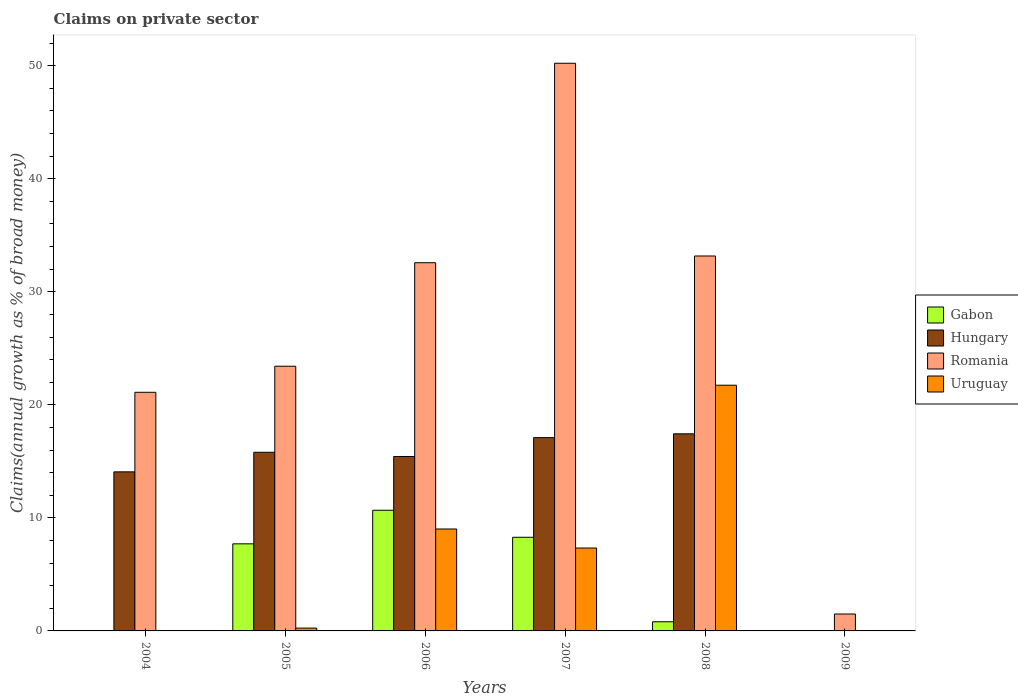How many different coloured bars are there?
Make the answer very short. 4. How many bars are there on the 1st tick from the left?
Your answer should be very brief. 2. How many bars are there on the 3rd tick from the right?
Make the answer very short. 4. What is the label of the 1st group of bars from the left?
Keep it short and to the point. 2004. In how many cases, is the number of bars for a given year not equal to the number of legend labels?
Offer a terse response. 2. What is the percentage of broad money claimed on private sector in Uruguay in 2008?
Make the answer very short. 21.74. Across all years, what is the maximum percentage of broad money claimed on private sector in Uruguay?
Provide a succinct answer. 21.74. Across all years, what is the minimum percentage of broad money claimed on private sector in Romania?
Give a very brief answer. 1.5. In which year was the percentage of broad money claimed on private sector in Hungary maximum?
Keep it short and to the point. 2008. What is the total percentage of broad money claimed on private sector in Romania in the graph?
Keep it short and to the point. 161.99. What is the difference between the percentage of broad money claimed on private sector in Hungary in 2005 and that in 2008?
Give a very brief answer. -1.63. What is the difference between the percentage of broad money claimed on private sector in Gabon in 2005 and the percentage of broad money claimed on private sector in Hungary in 2006?
Ensure brevity in your answer.  -7.73. What is the average percentage of broad money claimed on private sector in Gabon per year?
Provide a short and direct response. 4.58. In the year 2005, what is the difference between the percentage of broad money claimed on private sector in Gabon and percentage of broad money claimed on private sector in Hungary?
Make the answer very short. -8.1. What is the ratio of the percentage of broad money claimed on private sector in Hungary in 2005 to that in 2008?
Your response must be concise. 0.91. What is the difference between the highest and the second highest percentage of broad money claimed on private sector in Hungary?
Offer a very short reply. 0.34. What is the difference between the highest and the lowest percentage of broad money claimed on private sector in Hungary?
Your answer should be very brief. 17.44. Is the sum of the percentage of broad money claimed on private sector in Hungary in 2006 and 2007 greater than the maximum percentage of broad money claimed on private sector in Gabon across all years?
Offer a very short reply. Yes. Is it the case that in every year, the sum of the percentage of broad money claimed on private sector in Uruguay and percentage of broad money claimed on private sector in Romania is greater than the percentage of broad money claimed on private sector in Hungary?
Provide a succinct answer. Yes. Are all the bars in the graph horizontal?
Your response must be concise. No. How many years are there in the graph?
Your answer should be compact. 6. Where does the legend appear in the graph?
Your response must be concise. Center right. How many legend labels are there?
Give a very brief answer. 4. How are the legend labels stacked?
Your answer should be compact. Vertical. What is the title of the graph?
Offer a very short reply. Claims on private sector. Does "Mali" appear as one of the legend labels in the graph?
Your answer should be very brief. No. What is the label or title of the X-axis?
Your answer should be very brief. Years. What is the label or title of the Y-axis?
Offer a very short reply. Claims(annual growth as % of broad money). What is the Claims(annual growth as % of broad money) in Gabon in 2004?
Offer a terse response. 0. What is the Claims(annual growth as % of broad money) of Hungary in 2004?
Offer a very short reply. 14.07. What is the Claims(annual growth as % of broad money) in Romania in 2004?
Ensure brevity in your answer.  21.11. What is the Claims(annual growth as % of broad money) of Gabon in 2005?
Your answer should be compact. 7.7. What is the Claims(annual growth as % of broad money) of Hungary in 2005?
Provide a succinct answer. 15.8. What is the Claims(annual growth as % of broad money) in Romania in 2005?
Offer a very short reply. 23.42. What is the Claims(annual growth as % of broad money) of Uruguay in 2005?
Offer a very short reply. 0.25. What is the Claims(annual growth as % of broad money) of Gabon in 2006?
Ensure brevity in your answer.  10.68. What is the Claims(annual growth as % of broad money) in Hungary in 2006?
Give a very brief answer. 15.43. What is the Claims(annual growth as % of broad money) of Romania in 2006?
Your answer should be compact. 32.57. What is the Claims(annual growth as % of broad money) of Uruguay in 2006?
Provide a succinct answer. 9.02. What is the Claims(annual growth as % of broad money) in Gabon in 2007?
Your answer should be very brief. 8.28. What is the Claims(annual growth as % of broad money) in Hungary in 2007?
Make the answer very short. 17.1. What is the Claims(annual growth as % of broad money) in Romania in 2007?
Provide a succinct answer. 50.22. What is the Claims(annual growth as % of broad money) of Uruguay in 2007?
Ensure brevity in your answer.  7.33. What is the Claims(annual growth as % of broad money) in Gabon in 2008?
Offer a terse response. 0.81. What is the Claims(annual growth as % of broad money) in Hungary in 2008?
Give a very brief answer. 17.44. What is the Claims(annual growth as % of broad money) of Romania in 2008?
Your answer should be very brief. 33.17. What is the Claims(annual growth as % of broad money) of Uruguay in 2008?
Your answer should be compact. 21.74. What is the Claims(annual growth as % of broad money) in Gabon in 2009?
Make the answer very short. 0. What is the Claims(annual growth as % of broad money) in Hungary in 2009?
Give a very brief answer. 0. What is the Claims(annual growth as % of broad money) in Romania in 2009?
Make the answer very short. 1.5. What is the Claims(annual growth as % of broad money) in Uruguay in 2009?
Offer a very short reply. 0. Across all years, what is the maximum Claims(annual growth as % of broad money) of Gabon?
Offer a terse response. 10.68. Across all years, what is the maximum Claims(annual growth as % of broad money) in Hungary?
Your response must be concise. 17.44. Across all years, what is the maximum Claims(annual growth as % of broad money) in Romania?
Ensure brevity in your answer.  50.22. Across all years, what is the maximum Claims(annual growth as % of broad money) of Uruguay?
Give a very brief answer. 21.74. Across all years, what is the minimum Claims(annual growth as % of broad money) in Gabon?
Your response must be concise. 0. Across all years, what is the minimum Claims(annual growth as % of broad money) in Romania?
Provide a succinct answer. 1.5. What is the total Claims(annual growth as % of broad money) of Gabon in the graph?
Your response must be concise. 27.47. What is the total Claims(annual growth as % of broad money) in Hungary in the graph?
Keep it short and to the point. 79.84. What is the total Claims(annual growth as % of broad money) of Romania in the graph?
Offer a terse response. 161.99. What is the total Claims(annual growth as % of broad money) of Uruguay in the graph?
Ensure brevity in your answer.  38.34. What is the difference between the Claims(annual growth as % of broad money) in Hungary in 2004 and that in 2005?
Provide a short and direct response. -1.73. What is the difference between the Claims(annual growth as % of broad money) of Romania in 2004 and that in 2005?
Offer a very short reply. -2.31. What is the difference between the Claims(annual growth as % of broad money) in Hungary in 2004 and that in 2006?
Ensure brevity in your answer.  -1.36. What is the difference between the Claims(annual growth as % of broad money) of Romania in 2004 and that in 2006?
Give a very brief answer. -11.46. What is the difference between the Claims(annual growth as % of broad money) of Hungary in 2004 and that in 2007?
Give a very brief answer. -3.03. What is the difference between the Claims(annual growth as % of broad money) of Romania in 2004 and that in 2007?
Ensure brevity in your answer.  -29.11. What is the difference between the Claims(annual growth as % of broad money) in Hungary in 2004 and that in 2008?
Offer a very short reply. -3.36. What is the difference between the Claims(annual growth as % of broad money) of Romania in 2004 and that in 2008?
Offer a terse response. -12.06. What is the difference between the Claims(annual growth as % of broad money) of Romania in 2004 and that in 2009?
Your answer should be very brief. 19.61. What is the difference between the Claims(annual growth as % of broad money) of Gabon in 2005 and that in 2006?
Your response must be concise. -2.97. What is the difference between the Claims(annual growth as % of broad money) in Hungary in 2005 and that in 2006?
Your response must be concise. 0.37. What is the difference between the Claims(annual growth as % of broad money) of Romania in 2005 and that in 2006?
Offer a very short reply. -9.16. What is the difference between the Claims(annual growth as % of broad money) of Uruguay in 2005 and that in 2006?
Provide a succinct answer. -8.77. What is the difference between the Claims(annual growth as % of broad money) of Gabon in 2005 and that in 2007?
Provide a succinct answer. -0.58. What is the difference between the Claims(annual growth as % of broad money) in Hungary in 2005 and that in 2007?
Keep it short and to the point. -1.3. What is the difference between the Claims(annual growth as % of broad money) in Romania in 2005 and that in 2007?
Give a very brief answer. -26.8. What is the difference between the Claims(annual growth as % of broad money) of Uruguay in 2005 and that in 2007?
Keep it short and to the point. -7.08. What is the difference between the Claims(annual growth as % of broad money) of Gabon in 2005 and that in 2008?
Keep it short and to the point. 6.89. What is the difference between the Claims(annual growth as % of broad money) in Hungary in 2005 and that in 2008?
Your response must be concise. -1.63. What is the difference between the Claims(annual growth as % of broad money) in Romania in 2005 and that in 2008?
Offer a very short reply. -9.75. What is the difference between the Claims(annual growth as % of broad money) of Uruguay in 2005 and that in 2008?
Your response must be concise. -21.49. What is the difference between the Claims(annual growth as % of broad money) in Romania in 2005 and that in 2009?
Offer a terse response. 21.92. What is the difference between the Claims(annual growth as % of broad money) of Gabon in 2006 and that in 2007?
Provide a short and direct response. 2.39. What is the difference between the Claims(annual growth as % of broad money) in Hungary in 2006 and that in 2007?
Your response must be concise. -1.67. What is the difference between the Claims(annual growth as % of broad money) of Romania in 2006 and that in 2007?
Offer a terse response. -17.65. What is the difference between the Claims(annual growth as % of broad money) in Uruguay in 2006 and that in 2007?
Provide a short and direct response. 1.68. What is the difference between the Claims(annual growth as % of broad money) in Gabon in 2006 and that in 2008?
Provide a short and direct response. 9.86. What is the difference between the Claims(annual growth as % of broad money) in Hungary in 2006 and that in 2008?
Make the answer very short. -2.01. What is the difference between the Claims(annual growth as % of broad money) in Romania in 2006 and that in 2008?
Your answer should be compact. -0.6. What is the difference between the Claims(annual growth as % of broad money) of Uruguay in 2006 and that in 2008?
Provide a short and direct response. -12.72. What is the difference between the Claims(annual growth as % of broad money) of Romania in 2006 and that in 2009?
Keep it short and to the point. 31.08. What is the difference between the Claims(annual growth as % of broad money) in Gabon in 2007 and that in 2008?
Ensure brevity in your answer.  7.47. What is the difference between the Claims(annual growth as % of broad money) of Hungary in 2007 and that in 2008?
Offer a very short reply. -0.34. What is the difference between the Claims(annual growth as % of broad money) of Romania in 2007 and that in 2008?
Offer a terse response. 17.05. What is the difference between the Claims(annual growth as % of broad money) of Uruguay in 2007 and that in 2008?
Make the answer very short. -14.4. What is the difference between the Claims(annual growth as % of broad money) in Romania in 2007 and that in 2009?
Ensure brevity in your answer.  48.72. What is the difference between the Claims(annual growth as % of broad money) of Romania in 2008 and that in 2009?
Offer a terse response. 31.67. What is the difference between the Claims(annual growth as % of broad money) of Hungary in 2004 and the Claims(annual growth as % of broad money) of Romania in 2005?
Offer a terse response. -9.34. What is the difference between the Claims(annual growth as % of broad money) in Hungary in 2004 and the Claims(annual growth as % of broad money) in Uruguay in 2005?
Provide a short and direct response. 13.82. What is the difference between the Claims(annual growth as % of broad money) in Romania in 2004 and the Claims(annual growth as % of broad money) in Uruguay in 2005?
Provide a succinct answer. 20.86. What is the difference between the Claims(annual growth as % of broad money) in Hungary in 2004 and the Claims(annual growth as % of broad money) in Romania in 2006?
Provide a succinct answer. -18.5. What is the difference between the Claims(annual growth as % of broad money) of Hungary in 2004 and the Claims(annual growth as % of broad money) of Uruguay in 2006?
Offer a terse response. 5.05. What is the difference between the Claims(annual growth as % of broad money) of Romania in 2004 and the Claims(annual growth as % of broad money) of Uruguay in 2006?
Keep it short and to the point. 12.09. What is the difference between the Claims(annual growth as % of broad money) of Hungary in 2004 and the Claims(annual growth as % of broad money) of Romania in 2007?
Your response must be concise. -36.15. What is the difference between the Claims(annual growth as % of broad money) of Hungary in 2004 and the Claims(annual growth as % of broad money) of Uruguay in 2007?
Keep it short and to the point. 6.74. What is the difference between the Claims(annual growth as % of broad money) in Romania in 2004 and the Claims(annual growth as % of broad money) in Uruguay in 2007?
Ensure brevity in your answer.  13.78. What is the difference between the Claims(annual growth as % of broad money) in Hungary in 2004 and the Claims(annual growth as % of broad money) in Romania in 2008?
Offer a terse response. -19.1. What is the difference between the Claims(annual growth as % of broad money) of Hungary in 2004 and the Claims(annual growth as % of broad money) of Uruguay in 2008?
Ensure brevity in your answer.  -7.66. What is the difference between the Claims(annual growth as % of broad money) in Romania in 2004 and the Claims(annual growth as % of broad money) in Uruguay in 2008?
Provide a short and direct response. -0.63. What is the difference between the Claims(annual growth as % of broad money) in Hungary in 2004 and the Claims(annual growth as % of broad money) in Romania in 2009?
Offer a terse response. 12.58. What is the difference between the Claims(annual growth as % of broad money) of Gabon in 2005 and the Claims(annual growth as % of broad money) of Hungary in 2006?
Your answer should be very brief. -7.73. What is the difference between the Claims(annual growth as % of broad money) of Gabon in 2005 and the Claims(annual growth as % of broad money) of Romania in 2006?
Give a very brief answer. -24.87. What is the difference between the Claims(annual growth as % of broad money) of Gabon in 2005 and the Claims(annual growth as % of broad money) of Uruguay in 2006?
Provide a short and direct response. -1.31. What is the difference between the Claims(annual growth as % of broad money) of Hungary in 2005 and the Claims(annual growth as % of broad money) of Romania in 2006?
Provide a short and direct response. -16.77. What is the difference between the Claims(annual growth as % of broad money) of Hungary in 2005 and the Claims(annual growth as % of broad money) of Uruguay in 2006?
Your response must be concise. 6.79. What is the difference between the Claims(annual growth as % of broad money) in Romania in 2005 and the Claims(annual growth as % of broad money) in Uruguay in 2006?
Make the answer very short. 14.4. What is the difference between the Claims(annual growth as % of broad money) in Gabon in 2005 and the Claims(annual growth as % of broad money) in Hungary in 2007?
Offer a very short reply. -9.4. What is the difference between the Claims(annual growth as % of broad money) in Gabon in 2005 and the Claims(annual growth as % of broad money) in Romania in 2007?
Make the answer very short. -42.52. What is the difference between the Claims(annual growth as % of broad money) of Gabon in 2005 and the Claims(annual growth as % of broad money) of Uruguay in 2007?
Keep it short and to the point. 0.37. What is the difference between the Claims(annual growth as % of broad money) in Hungary in 2005 and the Claims(annual growth as % of broad money) in Romania in 2007?
Your answer should be very brief. -34.42. What is the difference between the Claims(annual growth as % of broad money) of Hungary in 2005 and the Claims(annual growth as % of broad money) of Uruguay in 2007?
Provide a short and direct response. 8.47. What is the difference between the Claims(annual growth as % of broad money) of Romania in 2005 and the Claims(annual growth as % of broad money) of Uruguay in 2007?
Provide a succinct answer. 16.08. What is the difference between the Claims(annual growth as % of broad money) in Gabon in 2005 and the Claims(annual growth as % of broad money) in Hungary in 2008?
Ensure brevity in your answer.  -9.73. What is the difference between the Claims(annual growth as % of broad money) in Gabon in 2005 and the Claims(annual growth as % of broad money) in Romania in 2008?
Your answer should be very brief. -25.46. What is the difference between the Claims(annual growth as % of broad money) of Gabon in 2005 and the Claims(annual growth as % of broad money) of Uruguay in 2008?
Give a very brief answer. -14.03. What is the difference between the Claims(annual growth as % of broad money) in Hungary in 2005 and the Claims(annual growth as % of broad money) in Romania in 2008?
Your response must be concise. -17.36. What is the difference between the Claims(annual growth as % of broad money) of Hungary in 2005 and the Claims(annual growth as % of broad money) of Uruguay in 2008?
Provide a short and direct response. -5.93. What is the difference between the Claims(annual growth as % of broad money) of Romania in 2005 and the Claims(annual growth as % of broad money) of Uruguay in 2008?
Ensure brevity in your answer.  1.68. What is the difference between the Claims(annual growth as % of broad money) in Gabon in 2005 and the Claims(annual growth as % of broad money) in Romania in 2009?
Your answer should be very brief. 6.21. What is the difference between the Claims(annual growth as % of broad money) of Hungary in 2005 and the Claims(annual growth as % of broad money) of Romania in 2009?
Ensure brevity in your answer.  14.31. What is the difference between the Claims(annual growth as % of broad money) in Gabon in 2006 and the Claims(annual growth as % of broad money) in Hungary in 2007?
Your response must be concise. -6.42. What is the difference between the Claims(annual growth as % of broad money) of Gabon in 2006 and the Claims(annual growth as % of broad money) of Romania in 2007?
Provide a short and direct response. -39.54. What is the difference between the Claims(annual growth as % of broad money) in Gabon in 2006 and the Claims(annual growth as % of broad money) in Uruguay in 2007?
Your response must be concise. 3.34. What is the difference between the Claims(annual growth as % of broad money) of Hungary in 2006 and the Claims(annual growth as % of broad money) of Romania in 2007?
Provide a short and direct response. -34.79. What is the difference between the Claims(annual growth as % of broad money) of Hungary in 2006 and the Claims(annual growth as % of broad money) of Uruguay in 2007?
Your response must be concise. 8.1. What is the difference between the Claims(annual growth as % of broad money) in Romania in 2006 and the Claims(annual growth as % of broad money) in Uruguay in 2007?
Make the answer very short. 25.24. What is the difference between the Claims(annual growth as % of broad money) in Gabon in 2006 and the Claims(annual growth as % of broad money) in Hungary in 2008?
Provide a short and direct response. -6.76. What is the difference between the Claims(annual growth as % of broad money) of Gabon in 2006 and the Claims(annual growth as % of broad money) of Romania in 2008?
Offer a very short reply. -22.49. What is the difference between the Claims(annual growth as % of broad money) of Gabon in 2006 and the Claims(annual growth as % of broad money) of Uruguay in 2008?
Provide a short and direct response. -11.06. What is the difference between the Claims(annual growth as % of broad money) of Hungary in 2006 and the Claims(annual growth as % of broad money) of Romania in 2008?
Give a very brief answer. -17.74. What is the difference between the Claims(annual growth as % of broad money) in Hungary in 2006 and the Claims(annual growth as % of broad money) in Uruguay in 2008?
Your response must be concise. -6.31. What is the difference between the Claims(annual growth as % of broad money) in Romania in 2006 and the Claims(annual growth as % of broad money) in Uruguay in 2008?
Your answer should be compact. 10.84. What is the difference between the Claims(annual growth as % of broad money) in Gabon in 2006 and the Claims(annual growth as % of broad money) in Romania in 2009?
Provide a succinct answer. 9.18. What is the difference between the Claims(annual growth as % of broad money) in Hungary in 2006 and the Claims(annual growth as % of broad money) in Romania in 2009?
Keep it short and to the point. 13.93. What is the difference between the Claims(annual growth as % of broad money) in Gabon in 2007 and the Claims(annual growth as % of broad money) in Hungary in 2008?
Offer a terse response. -9.15. What is the difference between the Claims(annual growth as % of broad money) of Gabon in 2007 and the Claims(annual growth as % of broad money) of Romania in 2008?
Give a very brief answer. -24.88. What is the difference between the Claims(annual growth as % of broad money) in Gabon in 2007 and the Claims(annual growth as % of broad money) in Uruguay in 2008?
Give a very brief answer. -13.45. What is the difference between the Claims(annual growth as % of broad money) in Hungary in 2007 and the Claims(annual growth as % of broad money) in Romania in 2008?
Provide a succinct answer. -16.07. What is the difference between the Claims(annual growth as % of broad money) in Hungary in 2007 and the Claims(annual growth as % of broad money) in Uruguay in 2008?
Your answer should be very brief. -4.64. What is the difference between the Claims(annual growth as % of broad money) in Romania in 2007 and the Claims(annual growth as % of broad money) in Uruguay in 2008?
Give a very brief answer. 28.48. What is the difference between the Claims(annual growth as % of broad money) of Gabon in 2007 and the Claims(annual growth as % of broad money) of Romania in 2009?
Ensure brevity in your answer.  6.79. What is the difference between the Claims(annual growth as % of broad money) in Hungary in 2007 and the Claims(annual growth as % of broad money) in Romania in 2009?
Your response must be concise. 15.6. What is the difference between the Claims(annual growth as % of broad money) of Gabon in 2008 and the Claims(annual growth as % of broad money) of Romania in 2009?
Keep it short and to the point. -0.69. What is the difference between the Claims(annual growth as % of broad money) of Hungary in 2008 and the Claims(annual growth as % of broad money) of Romania in 2009?
Make the answer very short. 15.94. What is the average Claims(annual growth as % of broad money) of Gabon per year?
Offer a very short reply. 4.58. What is the average Claims(annual growth as % of broad money) of Hungary per year?
Give a very brief answer. 13.31. What is the average Claims(annual growth as % of broad money) of Romania per year?
Your answer should be very brief. 27. What is the average Claims(annual growth as % of broad money) in Uruguay per year?
Your answer should be very brief. 6.39. In the year 2004, what is the difference between the Claims(annual growth as % of broad money) of Hungary and Claims(annual growth as % of broad money) of Romania?
Offer a very short reply. -7.04. In the year 2005, what is the difference between the Claims(annual growth as % of broad money) of Gabon and Claims(annual growth as % of broad money) of Hungary?
Your answer should be very brief. -8.1. In the year 2005, what is the difference between the Claims(annual growth as % of broad money) in Gabon and Claims(annual growth as % of broad money) in Romania?
Your answer should be compact. -15.71. In the year 2005, what is the difference between the Claims(annual growth as % of broad money) in Gabon and Claims(annual growth as % of broad money) in Uruguay?
Offer a very short reply. 7.45. In the year 2005, what is the difference between the Claims(annual growth as % of broad money) of Hungary and Claims(annual growth as % of broad money) of Romania?
Your response must be concise. -7.61. In the year 2005, what is the difference between the Claims(annual growth as % of broad money) in Hungary and Claims(annual growth as % of broad money) in Uruguay?
Your answer should be compact. 15.55. In the year 2005, what is the difference between the Claims(annual growth as % of broad money) of Romania and Claims(annual growth as % of broad money) of Uruguay?
Your answer should be very brief. 23.17. In the year 2006, what is the difference between the Claims(annual growth as % of broad money) of Gabon and Claims(annual growth as % of broad money) of Hungary?
Ensure brevity in your answer.  -4.76. In the year 2006, what is the difference between the Claims(annual growth as % of broad money) of Gabon and Claims(annual growth as % of broad money) of Romania?
Keep it short and to the point. -21.9. In the year 2006, what is the difference between the Claims(annual growth as % of broad money) in Gabon and Claims(annual growth as % of broad money) in Uruguay?
Ensure brevity in your answer.  1.66. In the year 2006, what is the difference between the Claims(annual growth as % of broad money) in Hungary and Claims(annual growth as % of broad money) in Romania?
Your answer should be compact. -17.14. In the year 2006, what is the difference between the Claims(annual growth as % of broad money) of Hungary and Claims(annual growth as % of broad money) of Uruguay?
Your response must be concise. 6.41. In the year 2006, what is the difference between the Claims(annual growth as % of broad money) in Romania and Claims(annual growth as % of broad money) in Uruguay?
Make the answer very short. 23.55. In the year 2007, what is the difference between the Claims(annual growth as % of broad money) of Gabon and Claims(annual growth as % of broad money) of Hungary?
Make the answer very short. -8.82. In the year 2007, what is the difference between the Claims(annual growth as % of broad money) in Gabon and Claims(annual growth as % of broad money) in Romania?
Provide a succinct answer. -41.94. In the year 2007, what is the difference between the Claims(annual growth as % of broad money) in Gabon and Claims(annual growth as % of broad money) in Uruguay?
Provide a short and direct response. 0.95. In the year 2007, what is the difference between the Claims(annual growth as % of broad money) of Hungary and Claims(annual growth as % of broad money) of Romania?
Offer a very short reply. -33.12. In the year 2007, what is the difference between the Claims(annual growth as % of broad money) of Hungary and Claims(annual growth as % of broad money) of Uruguay?
Offer a terse response. 9.77. In the year 2007, what is the difference between the Claims(annual growth as % of broad money) in Romania and Claims(annual growth as % of broad money) in Uruguay?
Your answer should be compact. 42.89. In the year 2008, what is the difference between the Claims(annual growth as % of broad money) of Gabon and Claims(annual growth as % of broad money) of Hungary?
Make the answer very short. -16.63. In the year 2008, what is the difference between the Claims(annual growth as % of broad money) in Gabon and Claims(annual growth as % of broad money) in Romania?
Ensure brevity in your answer.  -32.36. In the year 2008, what is the difference between the Claims(annual growth as % of broad money) in Gabon and Claims(annual growth as % of broad money) in Uruguay?
Your response must be concise. -20.93. In the year 2008, what is the difference between the Claims(annual growth as % of broad money) of Hungary and Claims(annual growth as % of broad money) of Romania?
Provide a succinct answer. -15.73. In the year 2008, what is the difference between the Claims(annual growth as % of broad money) of Hungary and Claims(annual growth as % of broad money) of Uruguay?
Ensure brevity in your answer.  -4.3. In the year 2008, what is the difference between the Claims(annual growth as % of broad money) in Romania and Claims(annual growth as % of broad money) in Uruguay?
Your response must be concise. 11.43. What is the ratio of the Claims(annual growth as % of broad money) in Hungary in 2004 to that in 2005?
Ensure brevity in your answer.  0.89. What is the ratio of the Claims(annual growth as % of broad money) in Romania in 2004 to that in 2005?
Offer a very short reply. 0.9. What is the ratio of the Claims(annual growth as % of broad money) of Hungary in 2004 to that in 2006?
Offer a very short reply. 0.91. What is the ratio of the Claims(annual growth as % of broad money) in Romania in 2004 to that in 2006?
Make the answer very short. 0.65. What is the ratio of the Claims(annual growth as % of broad money) in Hungary in 2004 to that in 2007?
Keep it short and to the point. 0.82. What is the ratio of the Claims(annual growth as % of broad money) of Romania in 2004 to that in 2007?
Make the answer very short. 0.42. What is the ratio of the Claims(annual growth as % of broad money) of Hungary in 2004 to that in 2008?
Offer a very short reply. 0.81. What is the ratio of the Claims(annual growth as % of broad money) of Romania in 2004 to that in 2008?
Ensure brevity in your answer.  0.64. What is the ratio of the Claims(annual growth as % of broad money) in Romania in 2004 to that in 2009?
Provide a short and direct response. 14.1. What is the ratio of the Claims(annual growth as % of broad money) in Gabon in 2005 to that in 2006?
Your answer should be compact. 0.72. What is the ratio of the Claims(annual growth as % of broad money) in Hungary in 2005 to that in 2006?
Keep it short and to the point. 1.02. What is the ratio of the Claims(annual growth as % of broad money) of Romania in 2005 to that in 2006?
Make the answer very short. 0.72. What is the ratio of the Claims(annual growth as % of broad money) in Uruguay in 2005 to that in 2006?
Your answer should be compact. 0.03. What is the ratio of the Claims(annual growth as % of broad money) in Gabon in 2005 to that in 2007?
Offer a terse response. 0.93. What is the ratio of the Claims(annual growth as % of broad money) of Hungary in 2005 to that in 2007?
Ensure brevity in your answer.  0.92. What is the ratio of the Claims(annual growth as % of broad money) in Romania in 2005 to that in 2007?
Provide a short and direct response. 0.47. What is the ratio of the Claims(annual growth as % of broad money) in Uruguay in 2005 to that in 2007?
Ensure brevity in your answer.  0.03. What is the ratio of the Claims(annual growth as % of broad money) of Gabon in 2005 to that in 2008?
Make the answer very short. 9.5. What is the ratio of the Claims(annual growth as % of broad money) of Hungary in 2005 to that in 2008?
Your answer should be very brief. 0.91. What is the ratio of the Claims(annual growth as % of broad money) in Romania in 2005 to that in 2008?
Your answer should be very brief. 0.71. What is the ratio of the Claims(annual growth as % of broad money) in Uruguay in 2005 to that in 2008?
Your answer should be compact. 0.01. What is the ratio of the Claims(annual growth as % of broad money) of Romania in 2005 to that in 2009?
Your answer should be very brief. 15.64. What is the ratio of the Claims(annual growth as % of broad money) of Gabon in 2006 to that in 2007?
Provide a short and direct response. 1.29. What is the ratio of the Claims(annual growth as % of broad money) of Hungary in 2006 to that in 2007?
Offer a terse response. 0.9. What is the ratio of the Claims(annual growth as % of broad money) of Romania in 2006 to that in 2007?
Give a very brief answer. 0.65. What is the ratio of the Claims(annual growth as % of broad money) of Uruguay in 2006 to that in 2007?
Offer a very short reply. 1.23. What is the ratio of the Claims(annual growth as % of broad money) of Gabon in 2006 to that in 2008?
Keep it short and to the point. 13.17. What is the ratio of the Claims(annual growth as % of broad money) in Hungary in 2006 to that in 2008?
Offer a very short reply. 0.89. What is the ratio of the Claims(annual growth as % of broad money) in Romania in 2006 to that in 2008?
Keep it short and to the point. 0.98. What is the ratio of the Claims(annual growth as % of broad money) of Uruguay in 2006 to that in 2008?
Provide a short and direct response. 0.41. What is the ratio of the Claims(annual growth as % of broad money) in Romania in 2006 to that in 2009?
Keep it short and to the point. 21.76. What is the ratio of the Claims(annual growth as % of broad money) in Gabon in 2007 to that in 2008?
Provide a succinct answer. 10.22. What is the ratio of the Claims(annual growth as % of broad money) of Hungary in 2007 to that in 2008?
Provide a succinct answer. 0.98. What is the ratio of the Claims(annual growth as % of broad money) of Romania in 2007 to that in 2008?
Offer a very short reply. 1.51. What is the ratio of the Claims(annual growth as % of broad money) in Uruguay in 2007 to that in 2008?
Keep it short and to the point. 0.34. What is the ratio of the Claims(annual growth as % of broad money) of Romania in 2007 to that in 2009?
Provide a short and direct response. 33.55. What is the ratio of the Claims(annual growth as % of broad money) of Romania in 2008 to that in 2009?
Your response must be concise. 22.16. What is the difference between the highest and the second highest Claims(annual growth as % of broad money) in Gabon?
Provide a succinct answer. 2.39. What is the difference between the highest and the second highest Claims(annual growth as % of broad money) in Hungary?
Provide a short and direct response. 0.34. What is the difference between the highest and the second highest Claims(annual growth as % of broad money) of Romania?
Your answer should be compact. 17.05. What is the difference between the highest and the second highest Claims(annual growth as % of broad money) of Uruguay?
Make the answer very short. 12.72. What is the difference between the highest and the lowest Claims(annual growth as % of broad money) in Gabon?
Ensure brevity in your answer.  10.68. What is the difference between the highest and the lowest Claims(annual growth as % of broad money) in Hungary?
Your answer should be very brief. 17.44. What is the difference between the highest and the lowest Claims(annual growth as % of broad money) of Romania?
Provide a short and direct response. 48.72. What is the difference between the highest and the lowest Claims(annual growth as % of broad money) of Uruguay?
Provide a short and direct response. 21.74. 